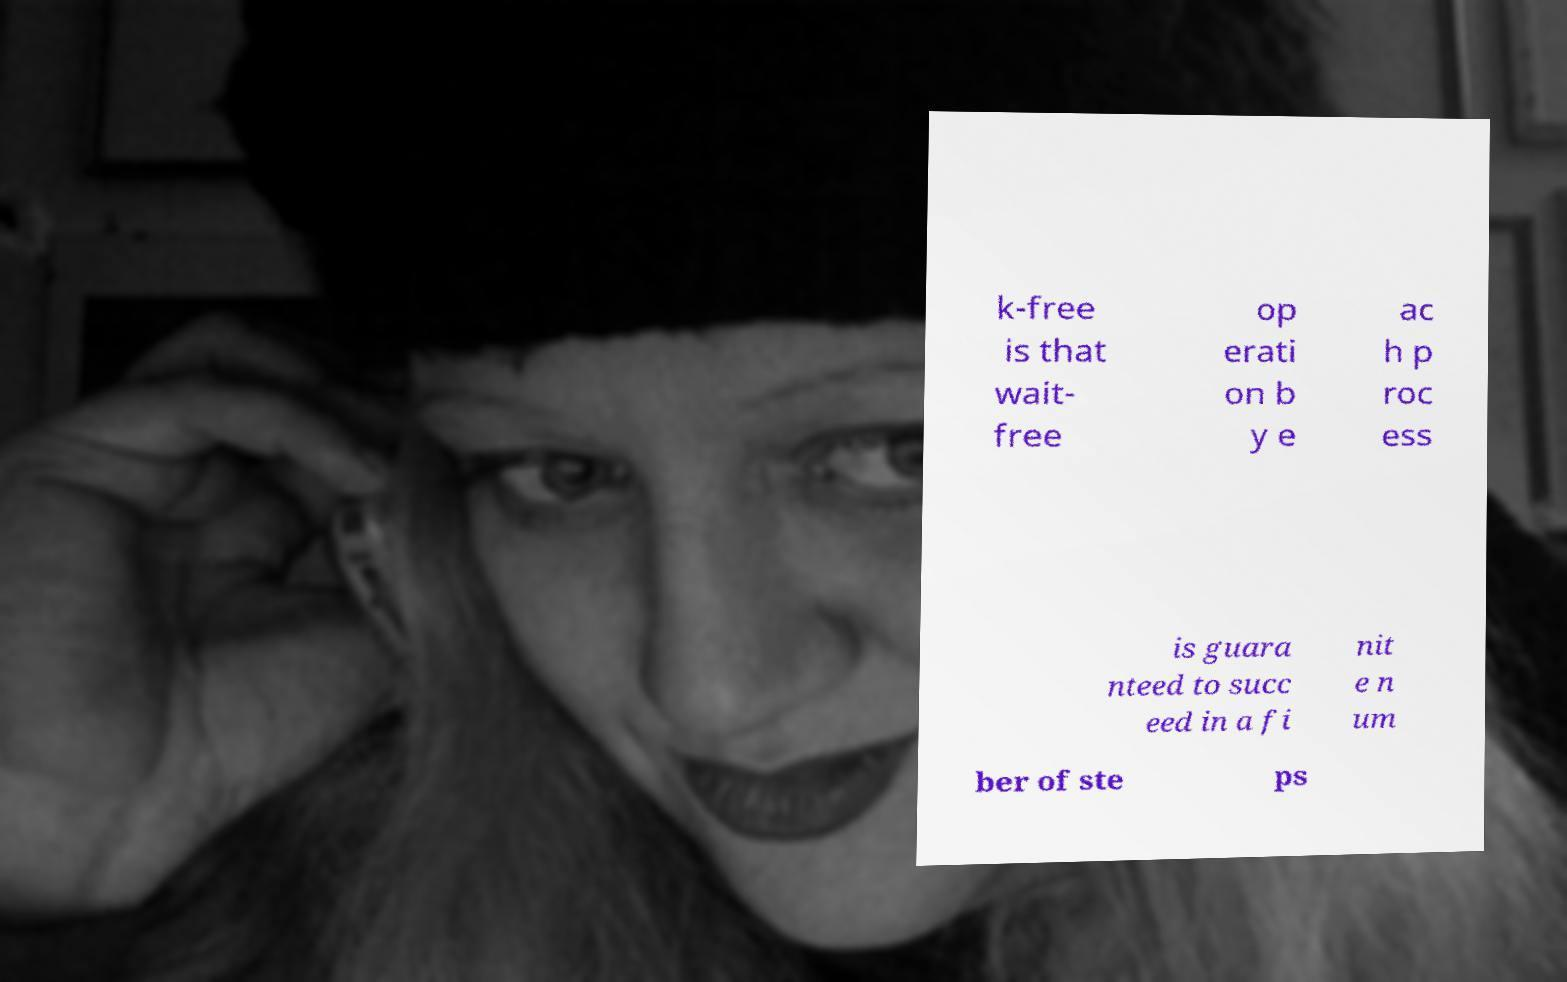Could you assist in decoding the text presented in this image and type it out clearly? k-free is that wait- free op erati on b y e ac h p roc ess is guara nteed to succ eed in a fi nit e n um ber of ste ps 